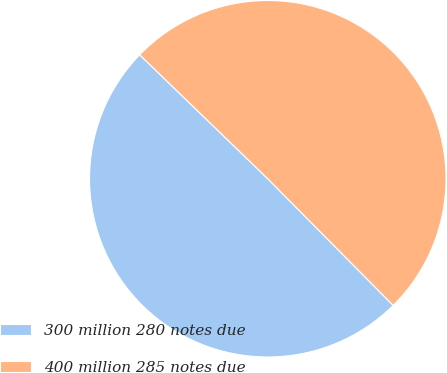Convert chart to OTSL. <chart><loc_0><loc_0><loc_500><loc_500><pie_chart><fcel>300 million 280 notes due<fcel>400 million 285 notes due<nl><fcel>49.66%<fcel>50.34%<nl></chart> 